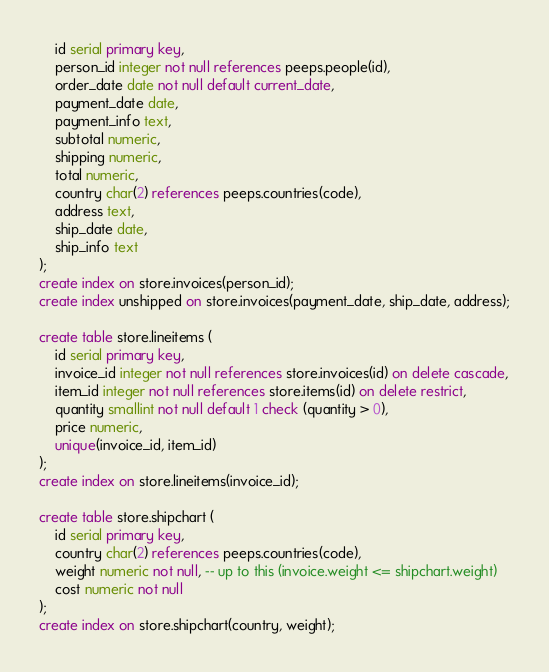Convert code to text. <code><loc_0><loc_0><loc_500><loc_500><_SQL_>	id serial primary key,
	person_id integer not null references peeps.people(id),
	order_date date not null default current_date,
	payment_date date,
	payment_info text,
	subtotal numeric,
	shipping numeric,
	total numeric,
	country char(2) references peeps.countries(code),
	address text,
	ship_date date,
	ship_info text
);
create index on store.invoices(person_id);
create index unshipped on store.invoices(payment_date, ship_date, address);

create table store.lineitems (
	id serial primary key,
	invoice_id integer not null references store.invoices(id) on delete cascade,
	item_id integer not null references store.items(id) on delete restrict,
	quantity smallint not null default 1 check (quantity > 0),
	price numeric,
	unique(invoice_id, item_id)
);
create index on store.lineitems(invoice_id);

create table store.shipchart (
	id serial primary key,
	country char(2) references peeps.countries(code),
	weight numeric not null, -- up to this (invoice.weight <= shipchart.weight)
	cost numeric not null
);
create index on store.shipchart(country, weight);

</code> 